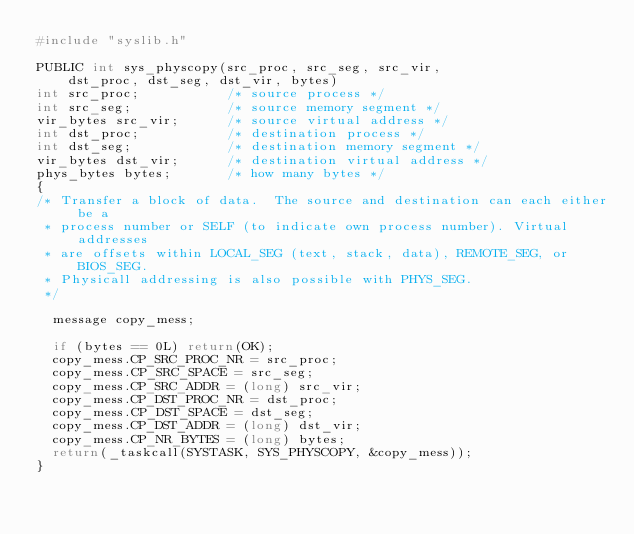<code> <loc_0><loc_0><loc_500><loc_500><_C_>#include "syslib.h"

PUBLIC int sys_physcopy(src_proc, src_seg, src_vir, 
	dst_proc, dst_seg, dst_vir, bytes)
int src_proc;			/* source process */
int src_seg;			/* source memory segment */
vir_bytes src_vir;		/* source virtual address */
int dst_proc;			/* destination process */
int dst_seg;			/* destination memory segment */
vir_bytes dst_vir;		/* destination virtual address */
phys_bytes bytes;		/* how many bytes */
{
/* Transfer a block of data.  The source and destination can each either be a
 * process number or SELF (to indicate own process number). Virtual addresses 
 * are offsets within LOCAL_SEG (text, stack, data), REMOTE_SEG, or BIOS_SEG. 
 * Physicall addressing is also possible with PHYS_SEG.
 */

  message copy_mess;

  if (bytes == 0L) return(OK);
  copy_mess.CP_SRC_PROC_NR = src_proc;
  copy_mess.CP_SRC_SPACE = src_seg;
  copy_mess.CP_SRC_ADDR = (long) src_vir;
  copy_mess.CP_DST_PROC_NR = dst_proc;
  copy_mess.CP_DST_SPACE = dst_seg;
  copy_mess.CP_DST_ADDR = (long) dst_vir;
  copy_mess.CP_NR_BYTES = (long) bytes;
  return(_taskcall(SYSTASK, SYS_PHYSCOPY, &copy_mess));
}
</code> 